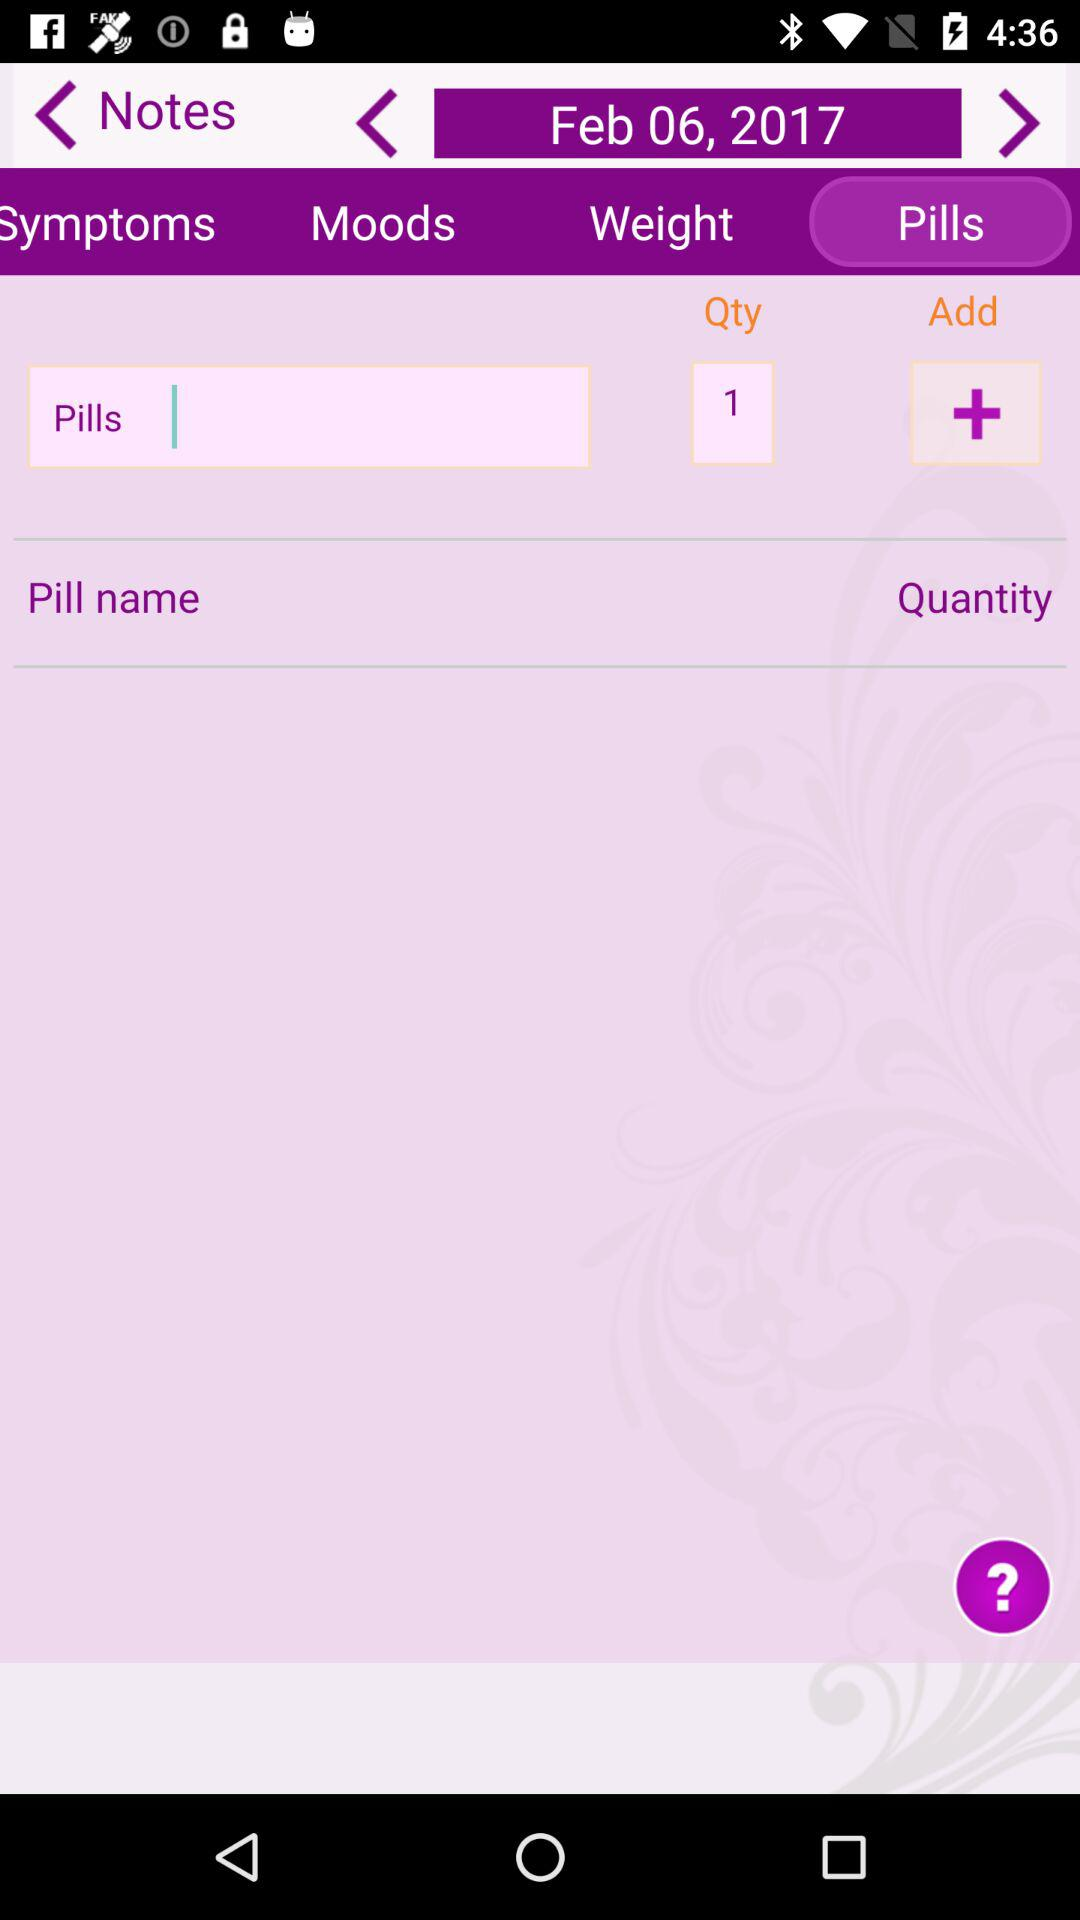Which option is selected? The selected option is "Pills". 